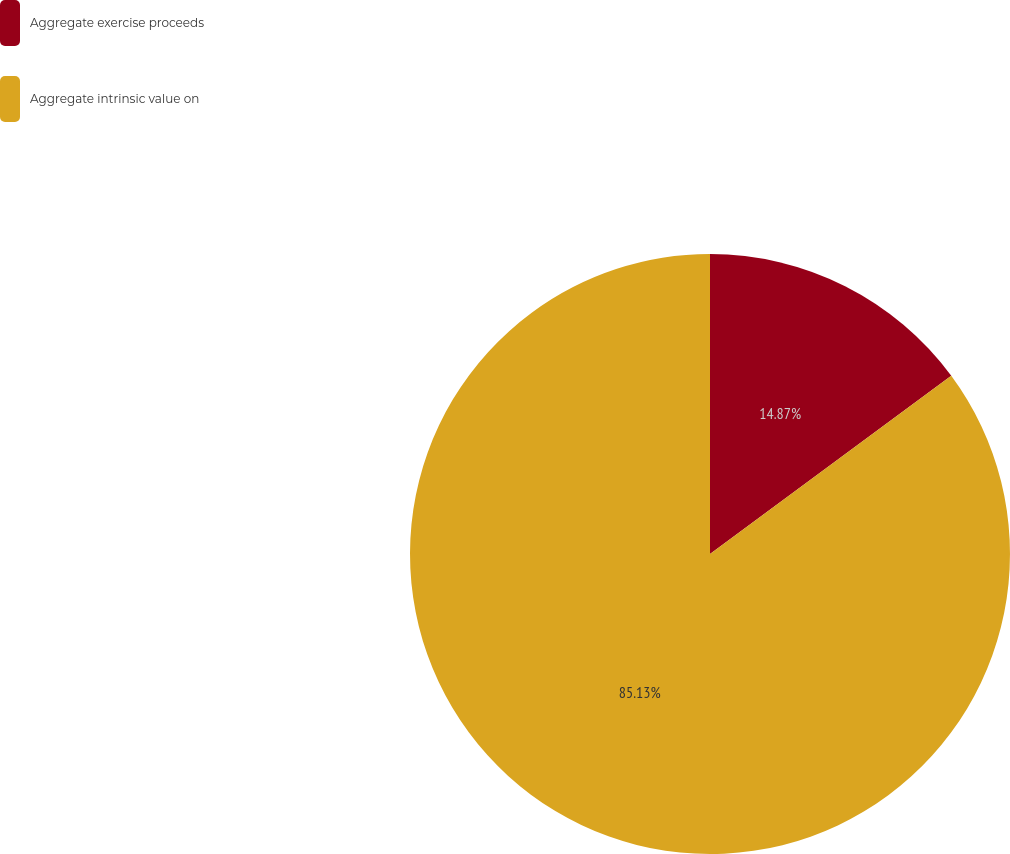Convert chart to OTSL. <chart><loc_0><loc_0><loc_500><loc_500><pie_chart><fcel>Aggregate exercise proceeds<fcel>Aggregate intrinsic value on<nl><fcel>14.87%<fcel>85.13%<nl></chart> 